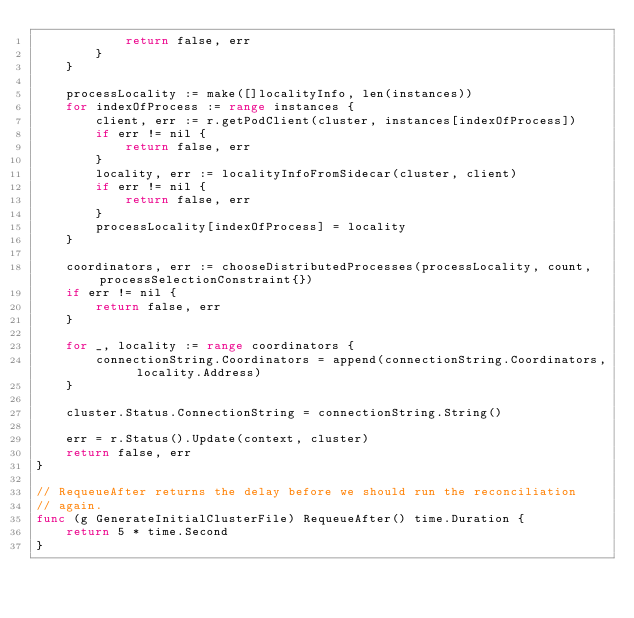Convert code to text. <code><loc_0><loc_0><loc_500><loc_500><_Go_>			return false, err
		}
	}

	processLocality := make([]localityInfo, len(instances))
	for indexOfProcess := range instances {
		client, err := r.getPodClient(cluster, instances[indexOfProcess])
		if err != nil {
			return false, err
		}
		locality, err := localityInfoFromSidecar(cluster, client)
		if err != nil {
			return false, err
		}
		processLocality[indexOfProcess] = locality
	}

	coordinators, err := chooseDistributedProcesses(processLocality, count, processSelectionConstraint{})
	if err != nil {
		return false, err
	}

	for _, locality := range coordinators {
		connectionString.Coordinators = append(connectionString.Coordinators, locality.Address)
	}

	cluster.Status.ConnectionString = connectionString.String()

	err = r.Status().Update(context, cluster)
	return false, err
}

// RequeueAfter returns the delay before we should run the reconciliation
// again.
func (g GenerateInitialClusterFile) RequeueAfter() time.Duration {
	return 5 * time.Second
}
</code> 